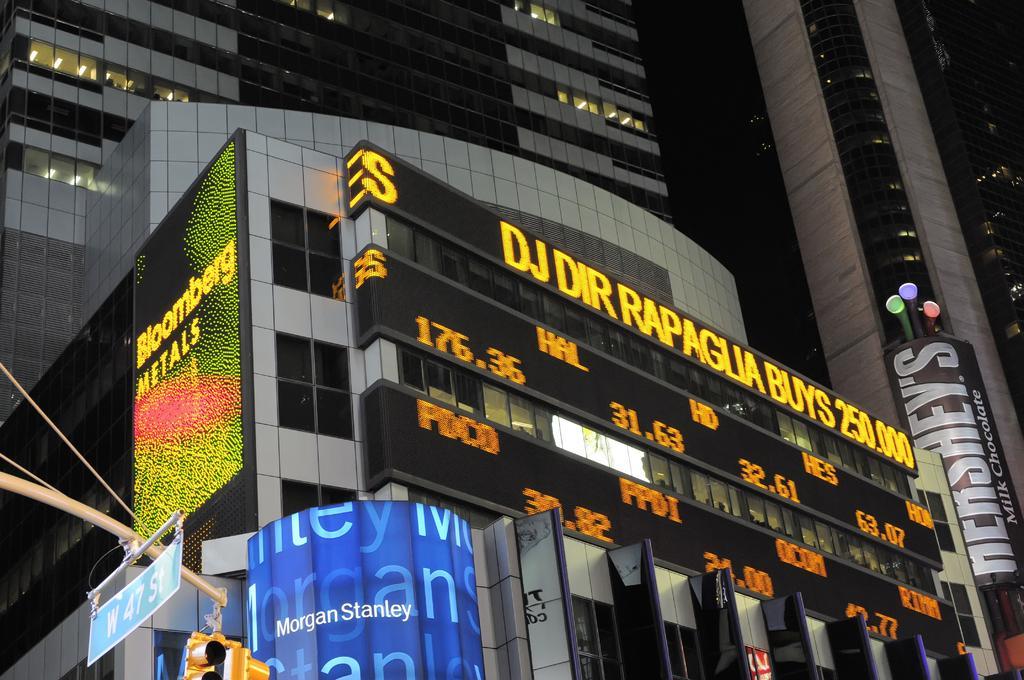Could you give a brief overview of what you see in this image? Here we can see buildings. On this building there are digital boards. These are hoardings, signboard and signal lights. 